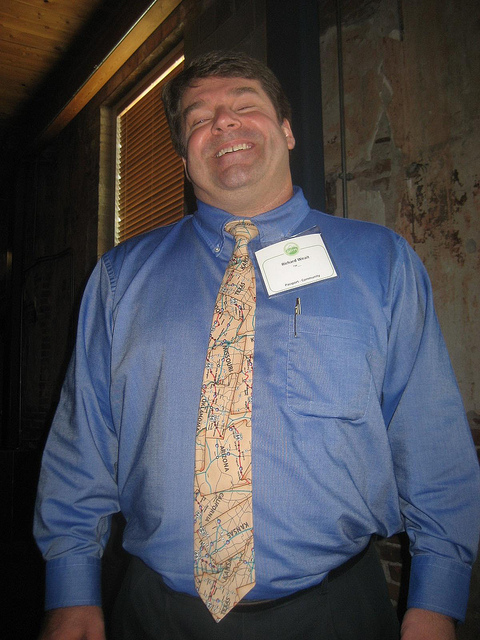Please identify all text content in this image. TEXAS MISSOURI ARIZONA CALIFORNIA KANSAS 